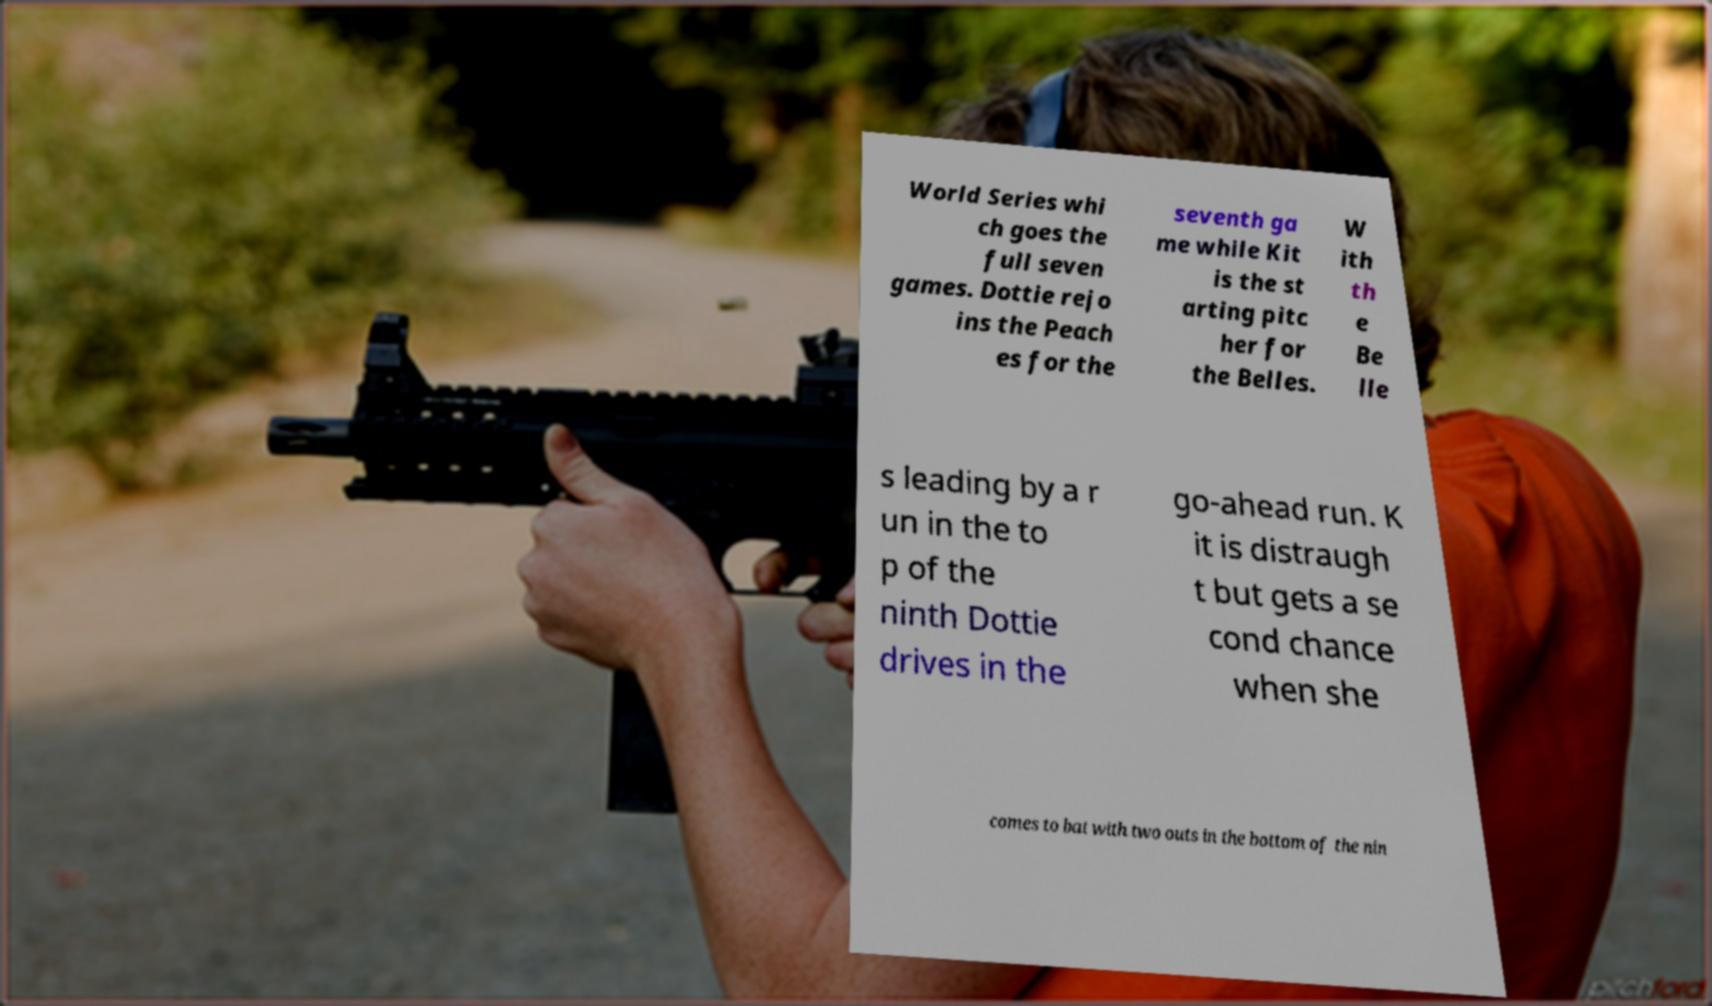For documentation purposes, I need the text within this image transcribed. Could you provide that? World Series whi ch goes the full seven games. Dottie rejo ins the Peach es for the seventh ga me while Kit is the st arting pitc her for the Belles. W ith th e Be lle s leading by a r un in the to p of the ninth Dottie drives in the go-ahead run. K it is distraugh t but gets a se cond chance when she comes to bat with two outs in the bottom of the nin 